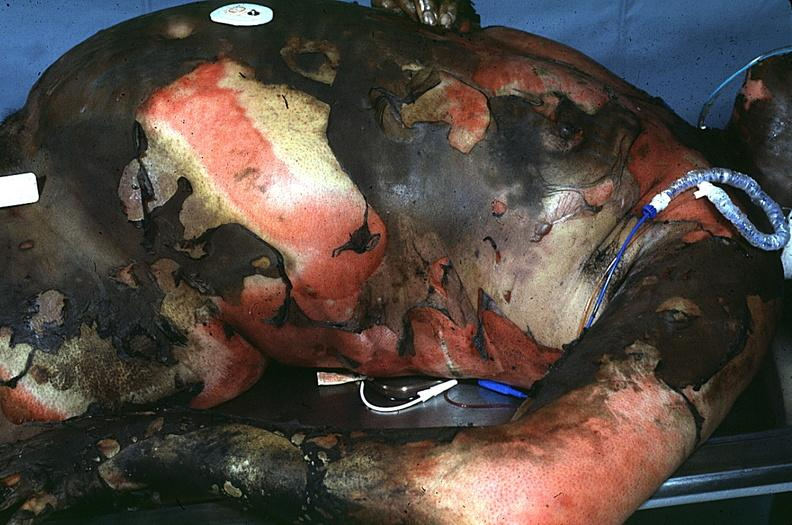what burn?
Answer the question using a single word or phrase. Thermal 